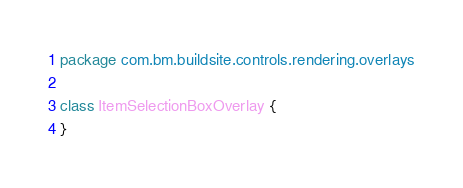<code> <loc_0><loc_0><loc_500><loc_500><_Kotlin_>package com.bm.buildsite.controls.rendering.overlays

class ItemSelectionBoxOverlay {
}</code> 